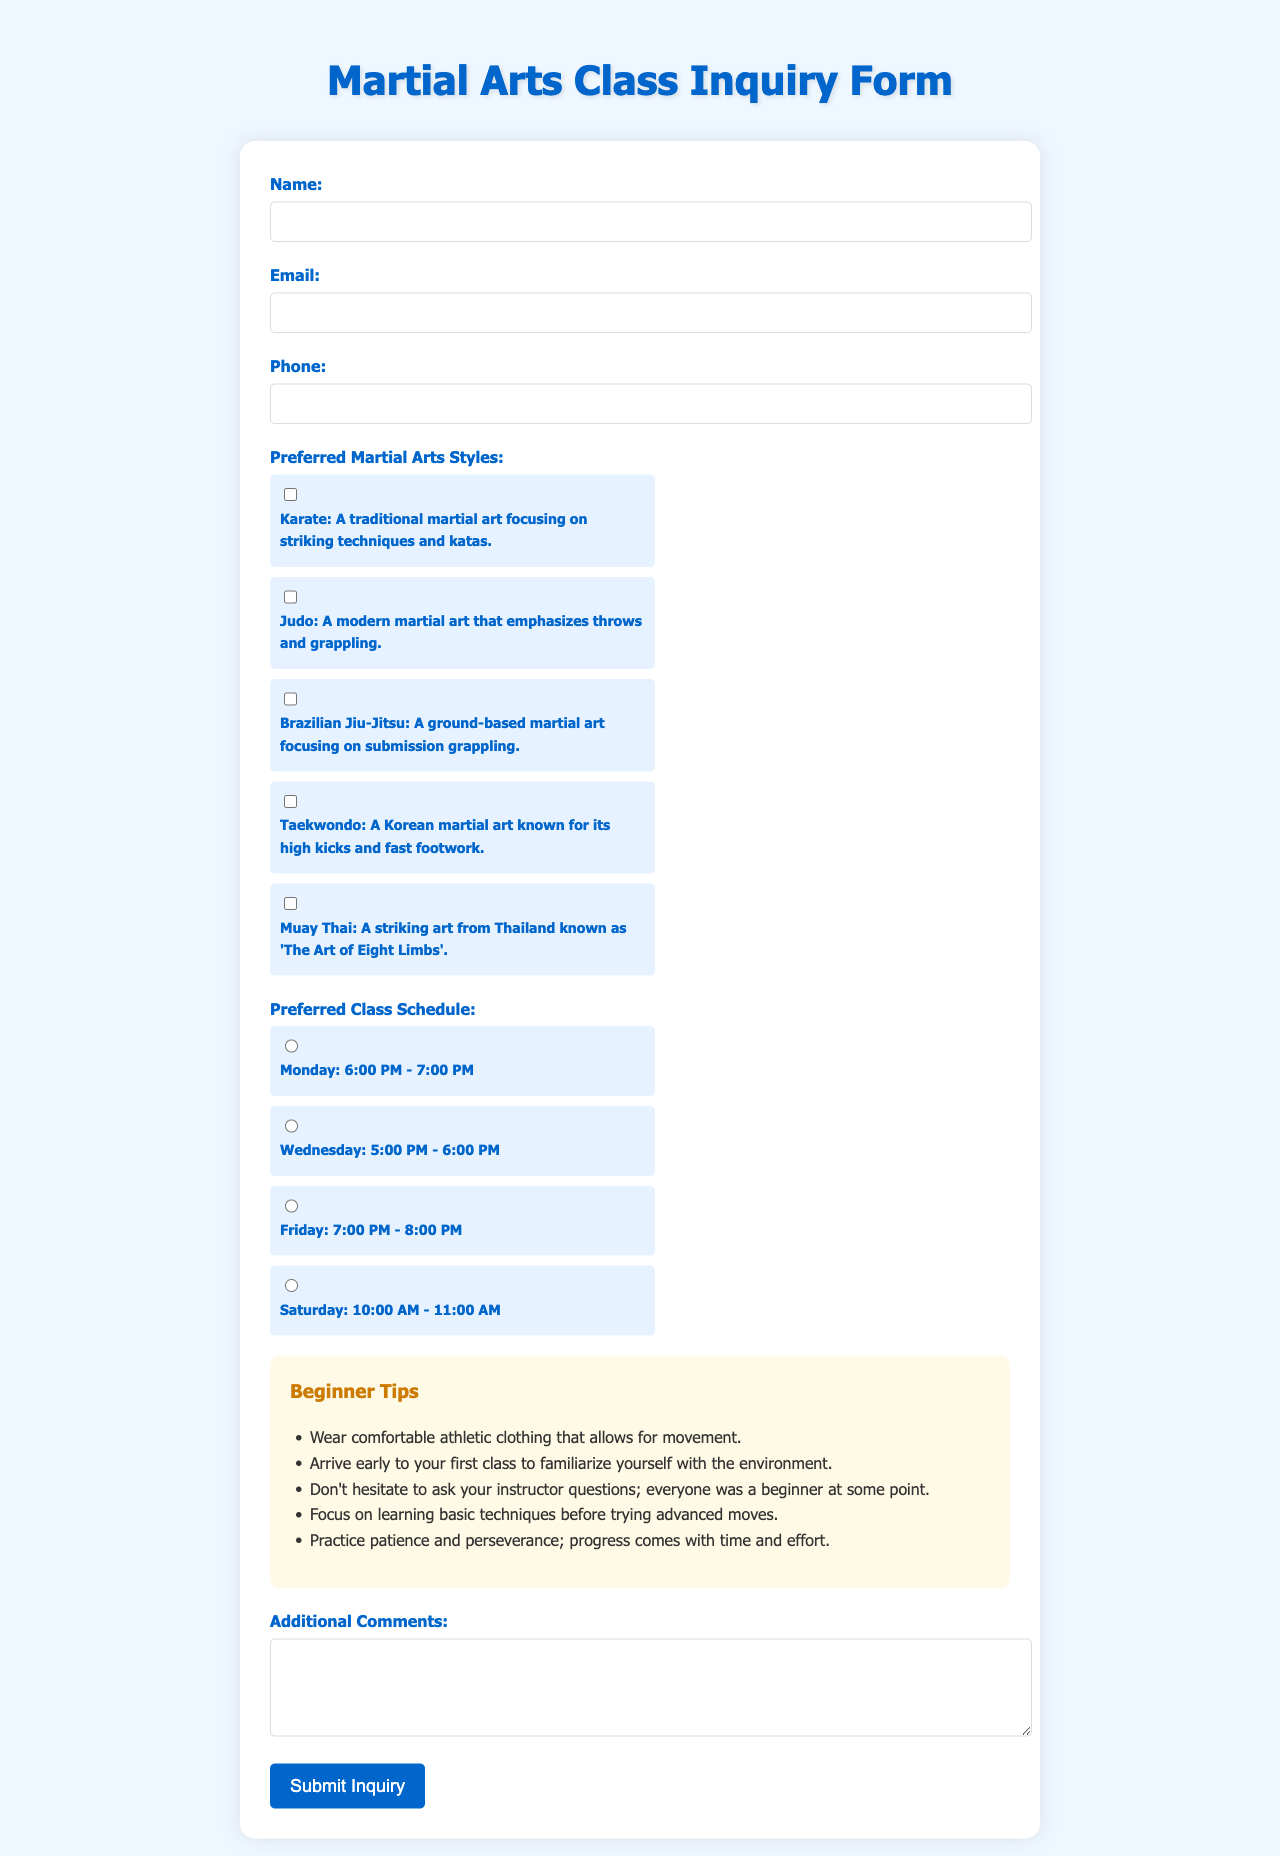What is the title of the document? The title is prominently displayed at the top of the form, indicating the purpose of the document.
Answer: Martial Arts Class Inquiry Form How many martial arts styles can be chosen? The document lists multiple styles available for selection in the form, indicating the variety offered.
Answer: Five What time does the Monday class start? The schedule indicates the specific timing for each class, including the Monday session.
Answer: 6:00 PM What is one tip provided for beginners? The document includes a section specifically dedicated to giving advice for newcomers to martial arts.
Answer: Wear comfortable athletic clothing Which day has a class scheduled at 10:00 AM? The document's class schedule provides specific times for sessions on different days, revealing the timing of each available class.
Answer: Saturday What type of input is requested in the comments section? The form has a designated area for additional feedback, indicating the information that can be provided.
Answer: Text What is the color theme of the document? The style and design choices are visible throughout the layout and color selection used in the document.
Answer: Blue and white 